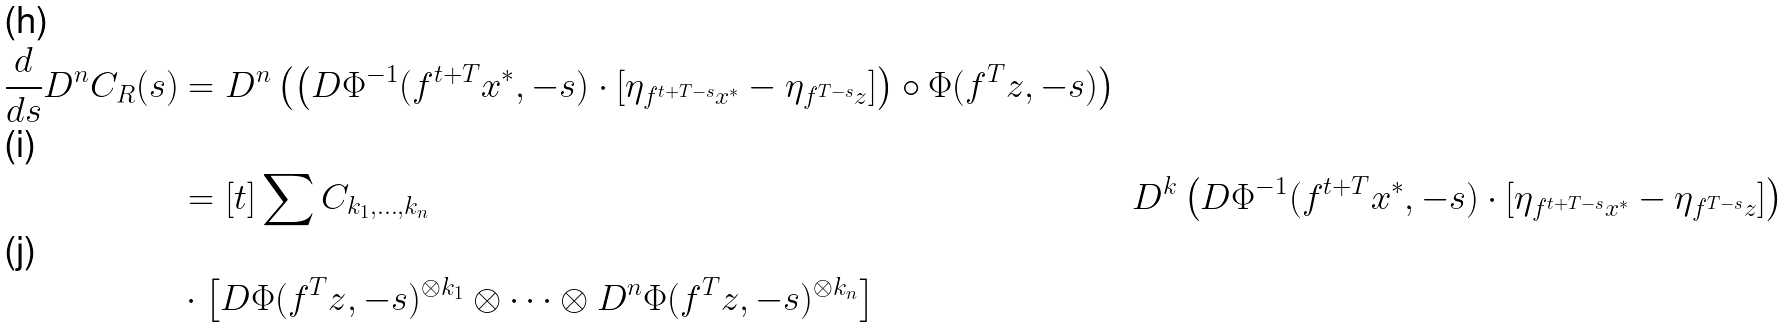Convert formula to latex. <formula><loc_0><loc_0><loc_500><loc_500>\frac { d } { d s } D ^ { n } C _ { R } ( s ) & = D ^ { n } \left ( \left ( D \Phi ^ { - 1 } ( f ^ { t + T } x ^ { * } , - s ) \cdot [ \eta _ { f ^ { t + T - s } x ^ { * } } - \eta _ { f ^ { T - s } z } ] \right ) \circ \Phi ( f ^ { T } z , - s ) \right ) \\ & = [ t ] \sum C _ { k _ { 1 } , \dots , k _ { n } } & D ^ { k } \left ( D \Phi ^ { - 1 } ( f ^ { t + T } x ^ { * } , - s ) \cdot [ \eta _ { f ^ { t + T - s } x ^ { * } } - \eta _ { f ^ { T - s } z } ] \right ) \\ & \cdot \left [ D \Phi ( f ^ { T } z , - s ) ^ { \otimes k _ { 1 } } \otimes \cdots \otimes D ^ { n } \Phi ( f ^ { T } z , - s ) ^ { \otimes k _ { n } } \right ]</formula> 